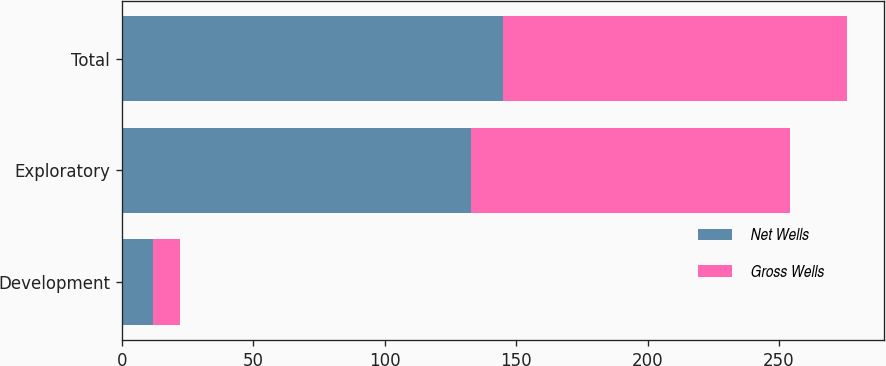Convert chart to OTSL. <chart><loc_0><loc_0><loc_500><loc_500><stacked_bar_chart><ecel><fcel>Development<fcel>Exploratory<fcel>Total<nl><fcel>Net Wells<fcel>12<fcel>133<fcel>145<nl><fcel>Gross Wells<fcel>10<fcel>121<fcel>131<nl></chart> 